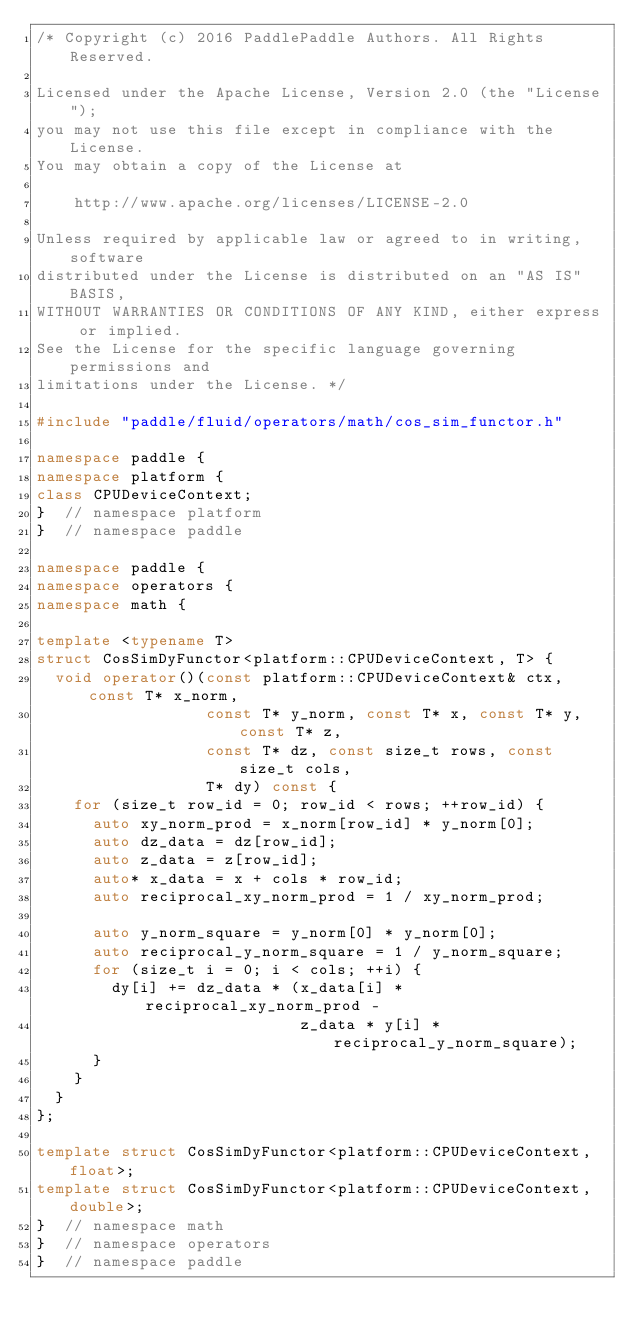<code> <loc_0><loc_0><loc_500><loc_500><_C++_>/* Copyright (c) 2016 PaddlePaddle Authors. All Rights Reserved.

Licensed under the Apache License, Version 2.0 (the "License");
you may not use this file except in compliance with the License.
You may obtain a copy of the License at

    http://www.apache.org/licenses/LICENSE-2.0

Unless required by applicable law or agreed to in writing, software
distributed under the License is distributed on an "AS IS" BASIS,
WITHOUT WARRANTIES OR CONDITIONS OF ANY KIND, either express or implied.
See the License for the specific language governing permissions and
limitations under the License. */

#include "paddle/fluid/operators/math/cos_sim_functor.h"

namespace paddle {
namespace platform {
class CPUDeviceContext;
}  // namespace platform
}  // namespace paddle

namespace paddle {
namespace operators {
namespace math {

template <typename T>
struct CosSimDyFunctor<platform::CPUDeviceContext, T> {
  void operator()(const platform::CPUDeviceContext& ctx, const T* x_norm,
                  const T* y_norm, const T* x, const T* y, const T* z,
                  const T* dz, const size_t rows, const size_t cols,
                  T* dy) const {
    for (size_t row_id = 0; row_id < rows; ++row_id) {
      auto xy_norm_prod = x_norm[row_id] * y_norm[0];
      auto dz_data = dz[row_id];
      auto z_data = z[row_id];
      auto* x_data = x + cols * row_id;
      auto reciprocal_xy_norm_prod = 1 / xy_norm_prod;

      auto y_norm_square = y_norm[0] * y_norm[0];
      auto reciprocal_y_norm_square = 1 / y_norm_square;
      for (size_t i = 0; i < cols; ++i) {
        dy[i] += dz_data * (x_data[i] * reciprocal_xy_norm_prod -
                            z_data * y[i] * reciprocal_y_norm_square);
      }
    }
  }
};

template struct CosSimDyFunctor<platform::CPUDeviceContext, float>;
template struct CosSimDyFunctor<platform::CPUDeviceContext, double>;
}  // namespace math
}  // namespace operators
}  // namespace paddle
</code> 